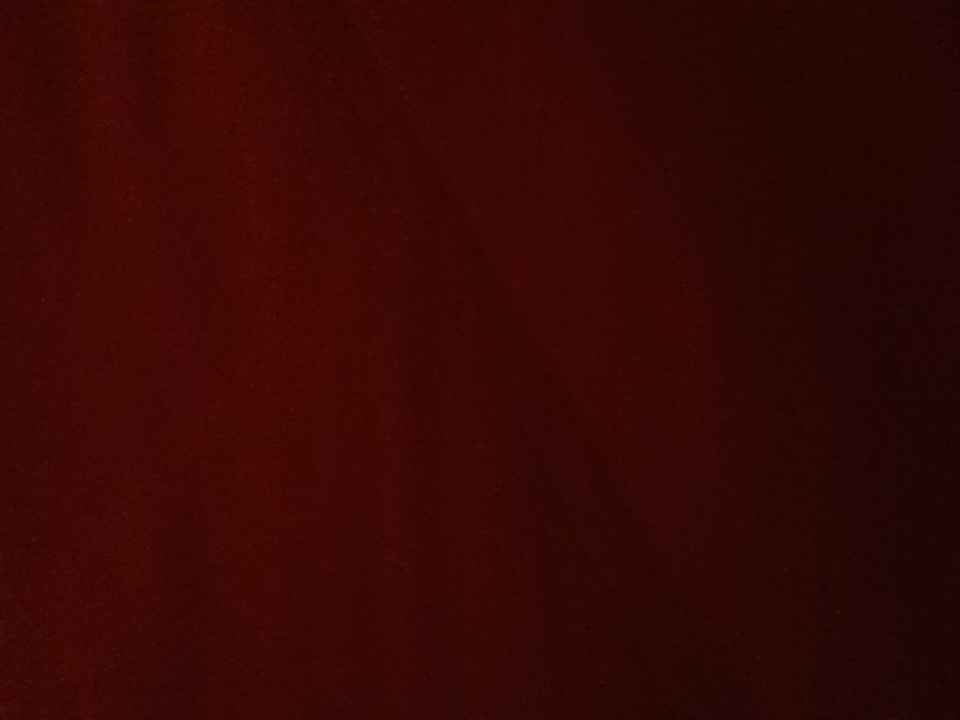How would this color appear in a realistic setting like a living room setup? In a living room, a deep red color like this could be used for a statement piece, such as a plush velvet sofa or a set of elegant curtains. The rich hue would add a touch of sophistication and warmth to the room, making it feel cozy yet luxurious. Paired with neutral tones like beige or grey, and accented with gold or brass details, this color would create a stylish and inviting space. Describe a short scenario where someone might use this color in their interior design. In a modern downtown loft, an artist decided to use this deep red as an accent wall in their studio. This bold choice not only highlighted their artwork but also inspired creativity and passion in their daily work, making the space feel both dynamic and personal. 